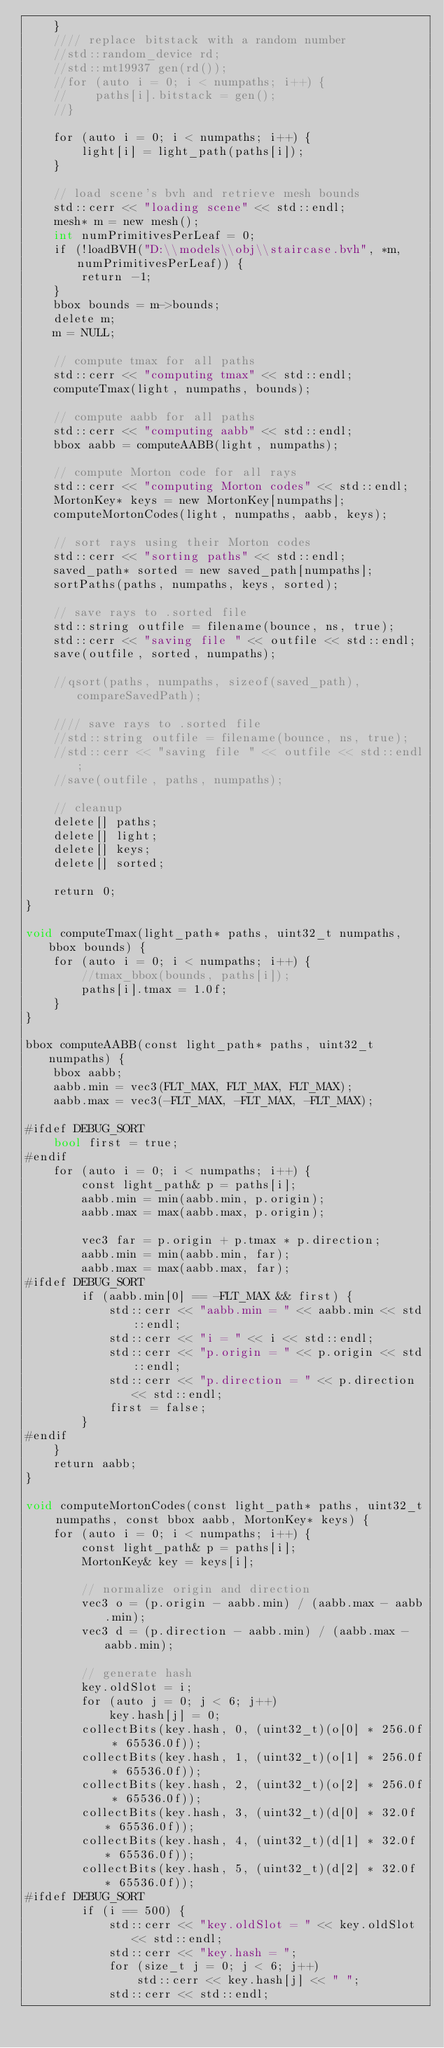Convert code to text. <code><loc_0><loc_0><loc_500><loc_500><_Cuda_>    }
    //// replace bitstack with a random number
    //std::random_device rd;
    //std::mt19937 gen(rd());
    //for (auto i = 0; i < numpaths; i++) {
    //    paths[i].bitstack = gen();
    //}

    for (auto i = 0; i < numpaths; i++) {
        light[i] = light_path(paths[i]);
    }

    // load scene's bvh and retrieve mesh bounds
    std::cerr << "loading scene" << std::endl;
    mesh* m = new mesh();
    int numPrimitivesPerLeaf = 0;
    if (!loadBVH("D:\\models\\obj\\staircase.bvh", *m, numPrimitivesPerLeaf)) {
        return -1;
    }
    bbox bounds = m->bounds;
    delete m;
    m = NULL;

    // compute tmax for all paths
    std::cerr << "computing tmax" << std::endl;
    computeTmax(light, numpaths, bounds);

    // compute aabb for all paths
    std::cerr << "computing aabb" << std::endl;
    bbox aabb = computeAABB(light, numpaths);

    // compute Morton code for all rays
    std::cerr << "computing Morton codes" << std::endl;
    MortonKey* keys = new MortonKey[numpaths];
    computeMortonCodes(light, numpaths, aabb, keys);

    // sort rays using their Morton codes
    std::cerr << "sorting paths" << std::endl;
    saved_path* sorted = new saved_path[numpaths];
    sortPaths(paths, numpaths, keys, sorted);

    // save rays to .sorted file
    std::string outfile = filename(bounce, ns, true);
    std::cerr << "saving file " << outfile << std::endl;
    save(outfile, sorted, numpaths);

    //qsort(paths, numpaths, sizeof(saved_path), compareSavedPath);

    //// save rays to .sorted file
    //std::string outfile = filename(bounce, ns, true);
    //std::cerr << "saving file " << outfile << std::endl;
    //save(outfile, paths, numpaths);

    // cleanup
    delete[] paths;
    delete[] light;
    delete[] keys;
    delete[] sorted;

    return 0;
}

void computeTmax(light_path* paths, uint32_t numpaths, bbox bounds) {
    for (auto i = 0; i < numpaths; i++) {
        //tmax_bbox(bounds, paths[i]);
        paths[i].tmax = 1.0f;
    }
}

bbox computeAABB(const light_path* paths, uint32_t numpaths) {
    bbox aabb;
    aabb.min = vec3(FLT_MAX, FLT_MAX, FLT_MAX);
    aabb.max = vec3(-FLT_MAX, -FLT_MAX, -FLT_MAX);

#ifdef DEBUG_SORT
    bool first = true;
#endif
    for (auto i = 0; i < numpaths; i++) {
        const light_path& p = paths[i];
        aabb.min = min(aabb.min, p.origin);
        aabb.max = max(aabb.max, p.origin);

        vec3 far = p.origin + p.tmax * p.direction;
        aabb.min = min(aabb.min, far);
        aabb.max = max(aabb.max, far);
#ifdef DEBUG_SORT
        if (aabb.min[0] == -FLT_MAX && first) {
            std::cerr << "aabb.min = " << aabb.min << std::endl;
            std::cerr << "i = " << i << std::endl;
            std::cerr << "p.origin = " << p.origin << std::endl;
            std::cerr << "p.direction = " << p.direction << std::endl;
            first = false;
        }
#endif
    }
    return aabb;
}

void computeMortonCodes(const light_path* paths, uint32_t numpaths, const bbox aabb, MortonKey* keys) {
    for (auto i = 0; i < numpaths; i++) {
        const light_path& p = paths[i];
        MortonKey& key = keys[i];

        // normalize origin and direction
        vec3 o = (p.origin - aabb.min) / (aabb.max - aabb.min);
        vec3 d = (p.direction - aabb.min) / (aabb.max - aabb.min);

        // generate hash
        key.oldSlot = i;
        for (auto j = 0; j < 6; j++)
            key.hash[j] = 0;
        collectBits(key.hash, 0, (uint32_t)(o[0] * 256.0f * 65536.0f));
        collectBits(key.hash, 1, (uint32_t)(o[1] * 256.0f * 65536.0f));
        collectBits(key.hash, 2, (uint32_t)(o[2] * 256.0f * 65536.0f));
        collectBits(key.hash, 3, (uint32_t)(d[0] * 32.0f * 65536.0f));
        collectBits(key.hash, 4, (uint32_t)(d[1] * 32.0f * 65536.0f));
        collectBits(key.hash, 5, (uint32_t)(d[2] * 32.0f * 65536.0f));
#ifdef DEBUG_SORT
        if (i == 500) {
            std::cerr << "key.oldSlot = " << key.oldSlot << std::endl;
            std::cerr << "key.hash = ";
            for (size_t j = 0; j < 6; j++)
                std::cerr << key.hash[j] << " ";
            std::cerr << std::endl;</code> 